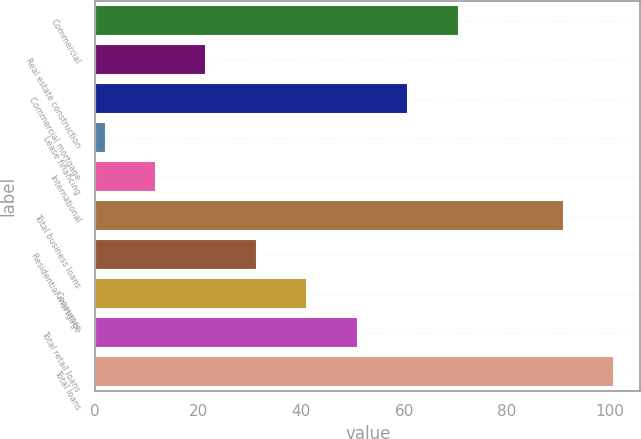Convert chart to OTSL. <chart><loc_0><loc_0><loc_500><loc_500><bar_chart><fcel>Commercial<fcel>Real estate construction<fcel>Commercial mortgage<fcel>Lease financing<fcel>International<fcel>Total business loans<fcel>Residential mortgage<fcel>Consumer<fcel>Total retail loans<fcel>Total loans<nl><fcel>70.6<fcel>21.6<fcel>60.8<fcel>2<fcel>11.8<fcel>91<fcel>31.4<fcel>41.2<fcel>51<fcel>100.8<nl></chart> 